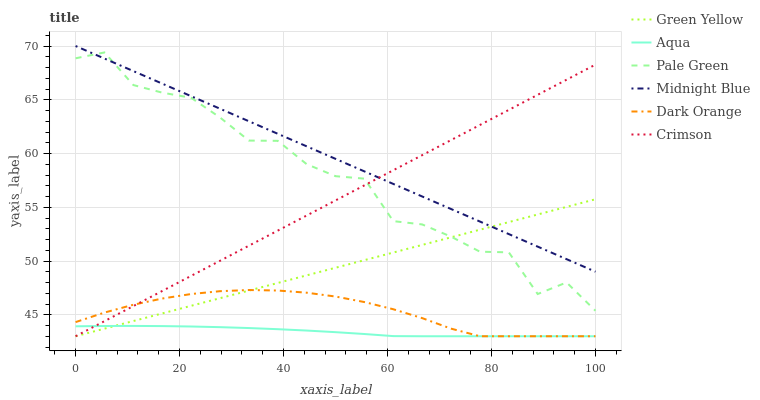Does Midnight Blue have the minimum area under the curve?
Answer yes or no. No. Does Aqua have the maximum area under the curve?
Answer yes or no. No. Is Aqua the smoothest?
Answer yes or no. No. Is Aqua the roughest?
Answer yes or no. No. Does Midnight Blue have the lowest value?
Answer yes or no. No. Does Aqua have the highest value?
Answer yes or no. No. Is Dark Orange less than Midnight Blue?
Answer yes or no. Yes. Is Midnight Blue greater than Dark Orange?
Answer yes or no. Yes. Does Dark Orange intersect Midnight Blue?
Answer yes or no. No. 